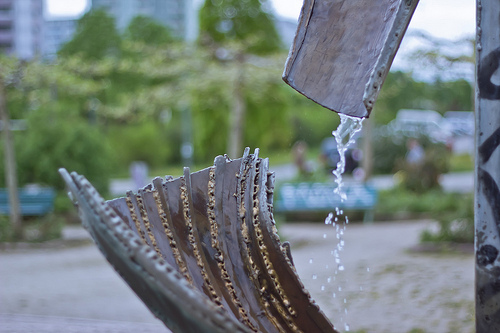<image>
Can you confirm if the drain is on the wood bowl? No. The drain is not positioned on the wood bowl. They may be near each other, but the drain is not supported by or resting on top of the wood bowl. 